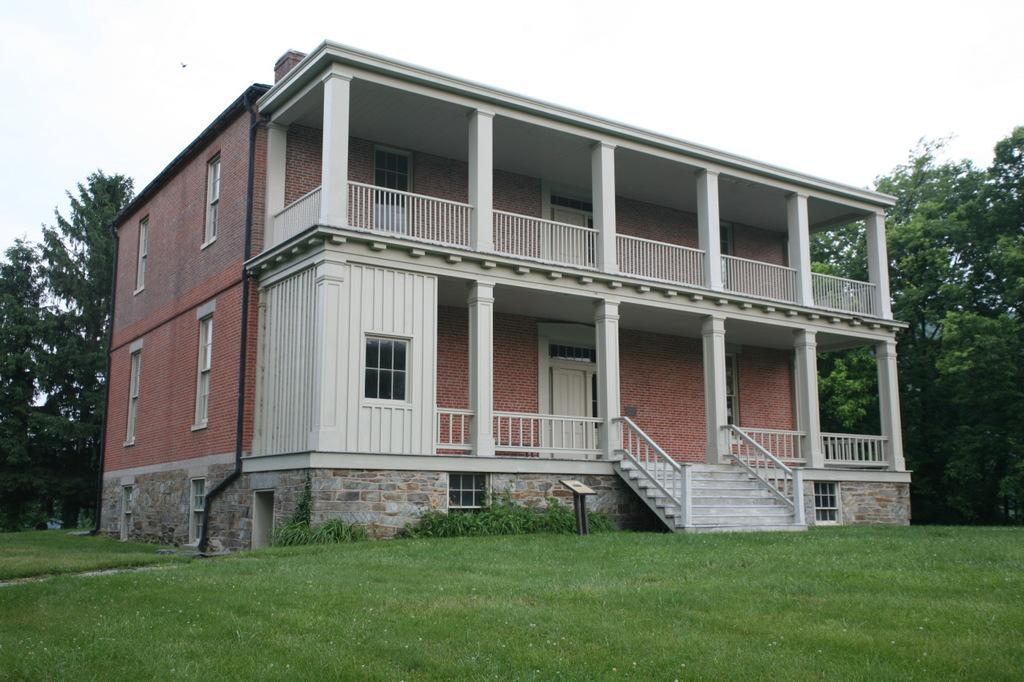What is the main structure in the center of the image? There is a house in the center of the image. What type of vegetation is at the bottom of the image? There is grass at the bottom of the image. What can be seen in the background of the image? There are trees and the sky visible in the background of the image. What is the condition of the sky in the image? Clouds are present in the background of the image. How many kitties are playing with the clouds in the image? There are no kitties present in the image, and therefore no such activity can be observed. 